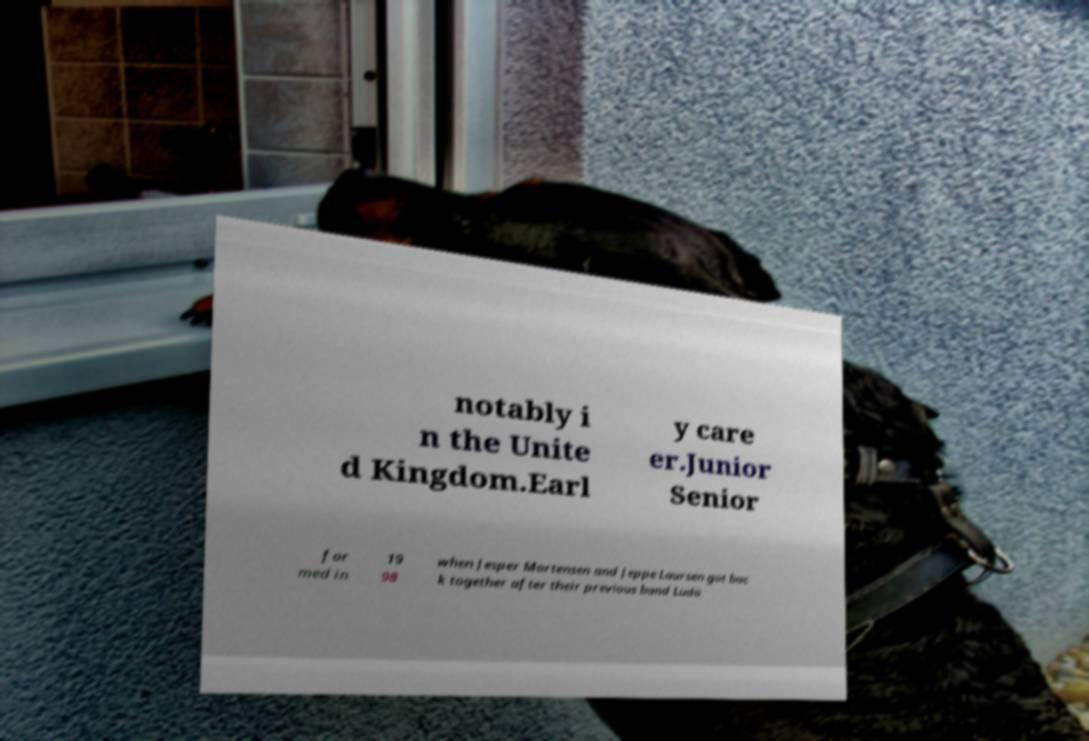Please read and relay the text visible in this image. What does it say? notably i n the Unite d Kingdom.Earl y care er.Junior Senior for med in 19 98 when Jesper Mortensen and Jeppe Laursen got bac k together after their previous band Ludo 